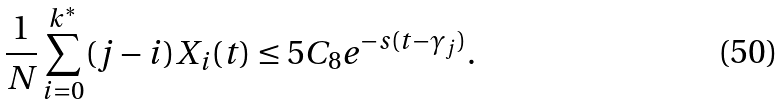<formula> <loc_0><loc_0><loc_500><loc_500>\frac { 1 } { N } \sum _ { i = 0 } ^ { k ^ { * } } ( j - i ) X _ { i } ( t ) \leq 5 C _ { 8 } e ^ { - s ( t - \gamma _ { j } ) } .</formula> 